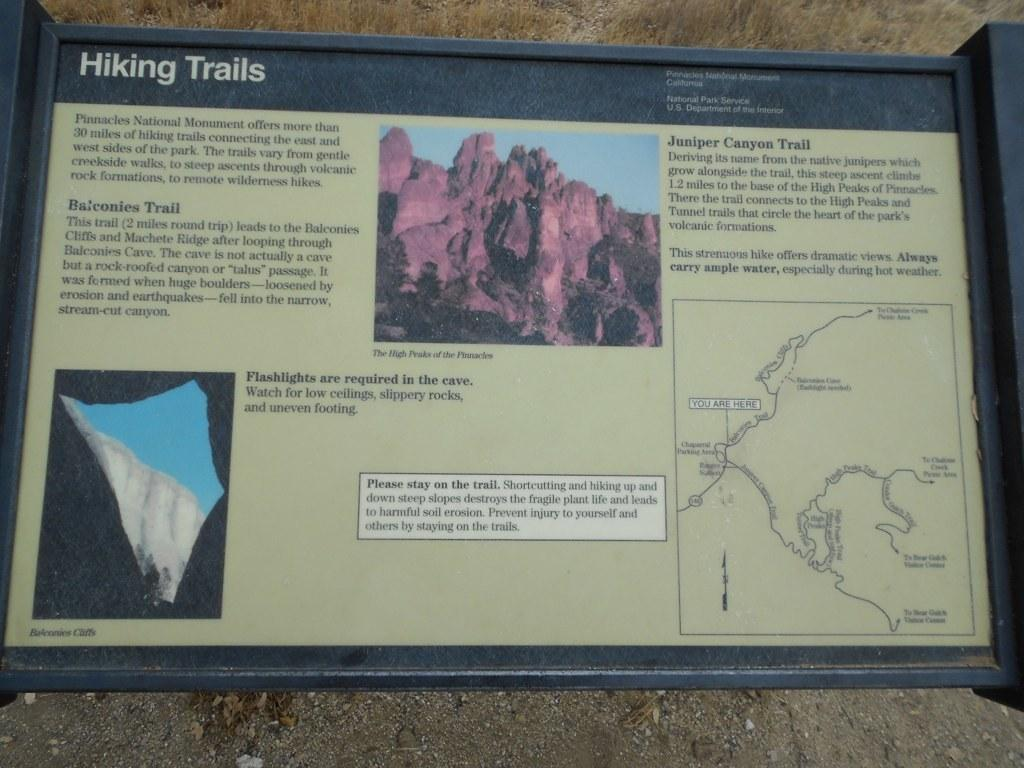<image>
Render a clear and concise summary of the photo. plaque for hiking trails featuring Balconies Trail and Juniper Canyon Trail 